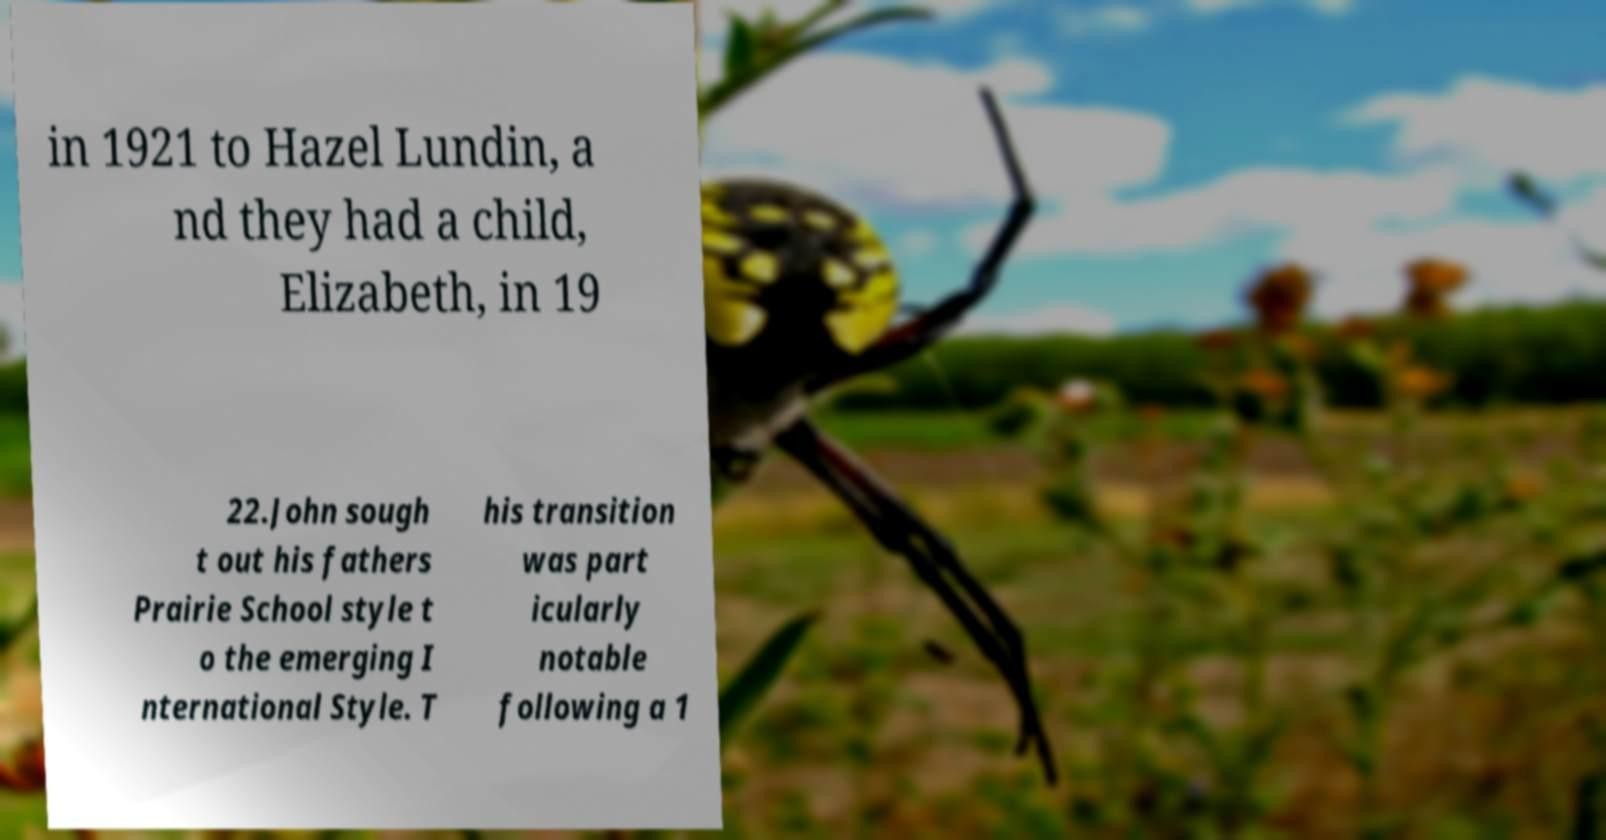For documentation purposes, I need the text within this image transcribed. Could you provide that? in 1921 to Hazel Lundin, a nd they had a child, Elizabeth, in 19 22.John sough t out his fathers Prairie School style t o the emerging I nternational Style. T his transition was part icularly notable following a 1 